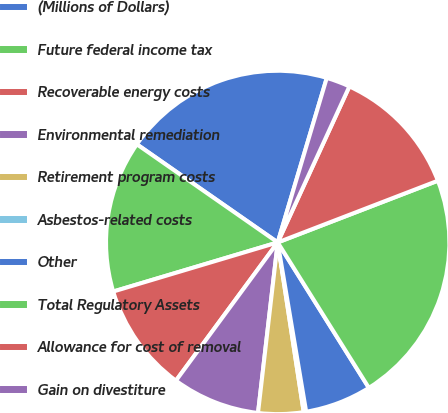<chart> <loc_0><loc_0><loc_500><loc_500><pie_chart><fcel>(Millions of Dollars)<fcel>Future federal income tax<fcel>Recoverable energy costs<fcel>Environmental remediation<fcel>Retirement program costs<fcel>Asbestos-related costs<fcel>Other<fcel>Total Regulatory Assets<fcel>Allowance for cost of removal<fcel>Gain on divestiture<nl><fcel>19.93%<fcel>14.3%<fcel>10.28%<fcel>8.27%<fcel>4.25%<fcel>0.23%<fcel>6.26%<fcel>21.94%<fcel>12.29%<fcel>2.24%<nl></chart> 